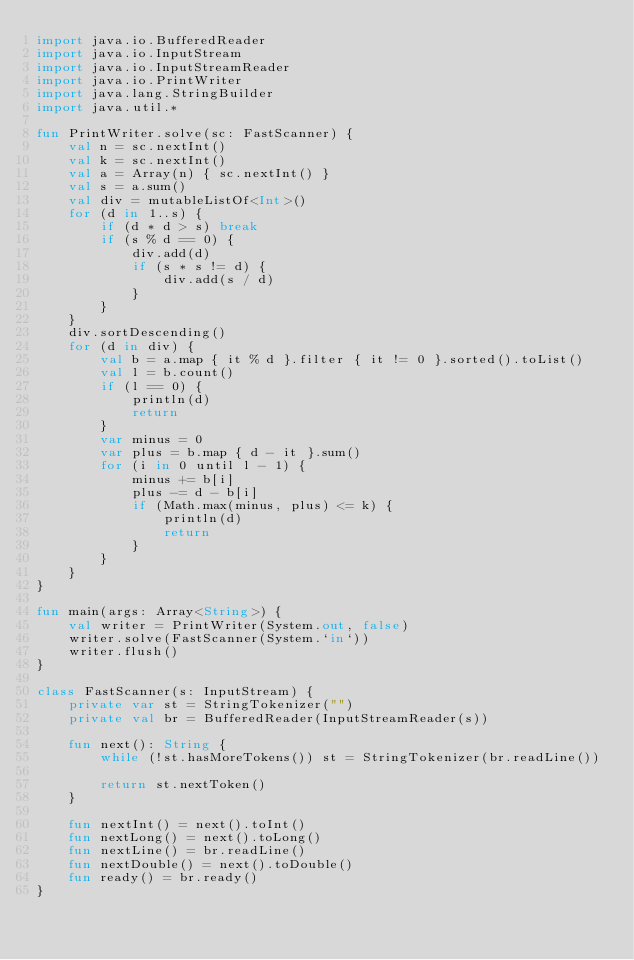Convert code to text. <code><loc_0><loc_0><loc_500><loc_500><_Kotlin_>import java.io.BufferedReader
import java.io.InputStream
import java.io.InputStreamReader
import java.io.PrintWriter
import java.lang.StringBuilder
import java.util.*

fun PrintWriter.solve(sc: FastScanner) {
    val n = sc.nextInt()
    val k = sc.nextInt()
    val a = Array(n) { sc.nextInt() }
    val s = a.sum()
    val div = mutableListOf<Int>()
    for (d in 1..s) {
        if (d * d > s) break
        if (s % d == 0) {
            div.add(d)
            if (s * s != d) {
                div.add(s / d)
            }
        }
    }
    div.sortDescending()
    for (d in div) {
        val b = a.map { it % d }.filter { it != 0 }.sorted().toList()
        val l = b.count()
        if (l == 0) {
            println(d)
            return
        }
        var minus = 0
        var plus = b.map { d - it }.sum()
        for (i in 0 until l - 1) {
            minus += b[i]
            plus -= d - b[i]
            if (Math.max(minus, plus) <= k) {
                println(d)
                return
            }
        }
    }
}

fun main(args: Array<String>) {
    val writer = PrintWriter(System.out, false)
    writer.solve(FastScanner(System.`in`))
    writer.flush()
}

class FastScanner(s: InputStream) {
    private var st = StringTokenizer("")
    private val br = BufferedReader(InputStreamReader(s))

    fun next(): String {
        while (!st.hasMoreTokens()) st = StringTokenizer(br.readLine())

        return st.nextToken()
    }

    fun nextInt() = next().toInt()
    fun nextLong() = next().toLong()
    fun nextLine() = br.readLine()
    fun nextDouble() = next().toDouble()
    fun ready() = br.ready()
}
</code> 